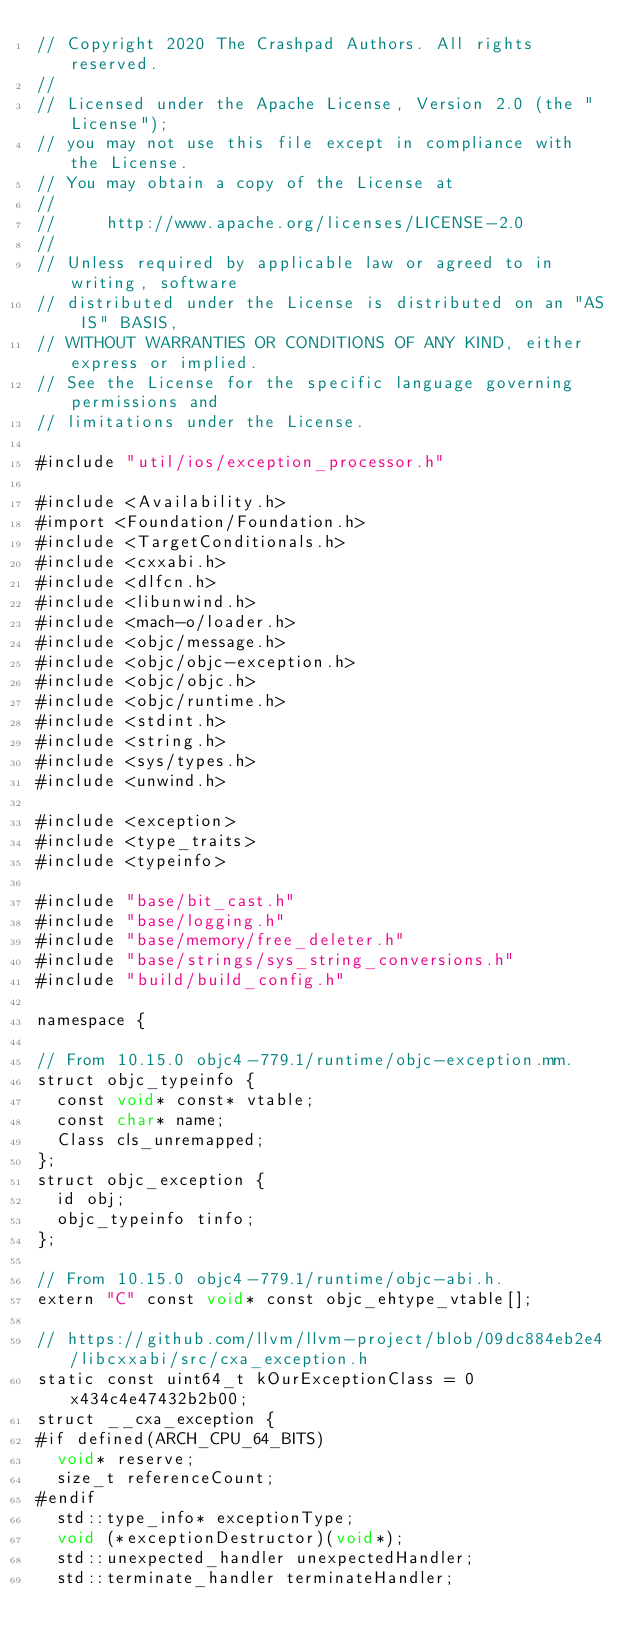Convert code to text. <code><loc_0><loc_0><loc_500><loc_500><_ObjectiveC_>// Copyright 2020 The Crashpad Authors. All rights reserved.
//
// Licensed under the Apache License, Version 2.0 (the "License");
// you may not use this file except in compliance with the License.
// You may obtain a copy of the License at
//
//     http://www.apache.org/licenses/LICENSE-2.0
//
// Unless required by applicable law or agreed to in writing, software
// distributed under the License is distributed on an "AS IS" BASIS,
// WITHOUT WARRANTIES OR CONDITIONS OF ANY KIND, either express or implied.
// See the License for the specific language governing permissions and
// limitations under the License.

#include "util/ios/exception_processor.h"

#include <Availability.h>
#import <Foundation/Foundation.h>
#include <TargetConditionals.h>
#include <cxxabi.h>
#include <dlfcn.h>
#include <libunwind.h>
#include <mach-o/loader.h>
#include <objc/message.h>
#include <objc/objc-exception.h>
#include <objc/objc.h>
#include <objc/runtime.h>
#include <stdint.h>
#include <string.h>
#include <sys/types.h>
#include <unwind.h>

#include <exception>
#include <type_traits>
#include <typeinfo>

#include "base/bit_cast.h"
#include "base/logging.h"
#include "base/memory/free_deleter.h"
#include "base/strings/sys_string_conversions.h"
#include "build/build_config.h"

namespace {

// From 10.15.0 objc4-779.1/runtime/objc-exception.mm.
struct objc_typeinfo {
  const void* const* vtable;
  const char* name;
  Class cls_unremapped;
};
struct objc_exception {
  id obj;
  objc_typeinfo tinfo;
};

// From 10.15.0 objc4-779.1/runtime/objc-abi.h.
extern "C" const void* const objc_ehtype_vtable[];

// https://github.com/llvm/llvm-project/blob/09dc884eb2e4/libcxxabi/src/cxa_exception.h
static const uint64_t kOurExceptionClass = 0x434c4e47432b2b00;
struct __cxa_exception {
#if defined(ARCH_CPU_64_BITS)
  void* reserve;
  size_t referenceCount;
#endif
  std::type_info* exceptionType;
  void (*exceptionDestructor)(void*);
  std::unexpected_handler unexpectedHandler;
  std::terminate_handler terminateHandler;</code> 